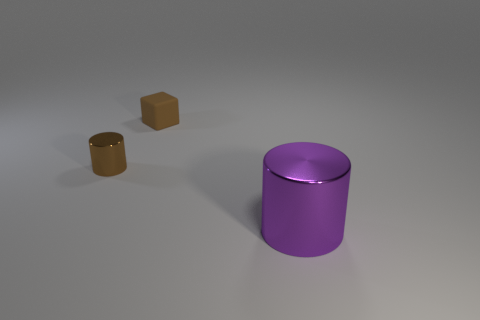Is there anything else that is the same shape as the brown matte thing?
Give a very brief answer. No. Is the material of the brown thing that is left of the brown cube the same as the small brown object that is on the right side of the tiny brown metallic object?
Ensure brevity in your answer.  No. What shape is the metal thing that is behind the purple thing on the right side of the small brown cube?
Provide a short and direct response. Cylinder. What color is the other small thing that is made of the same material as the purple object?
Your answer should be compact. Brown. Do the matte thing and the tiny metal object have the same color?
Offer a terse response. Yes. The brown shiny thing that is the same size as the brown matte thing is what shape?
Offer a very short reply. Cylinder. The matte thing is what size?
Provide a short and direct response. Small. There is a cylinder that is left of the purple object; is it the same size as the brown thing behind the small metal thing?
Provide a succinct answer. Yes. There is a cylinder that is to the right of the metallic object behind the big shiny thing; what color is it?
Make the answer very short. Purple. What is the material of the object that is the same size as the brown cylinder?
Offer a very short reply. Rubber. 